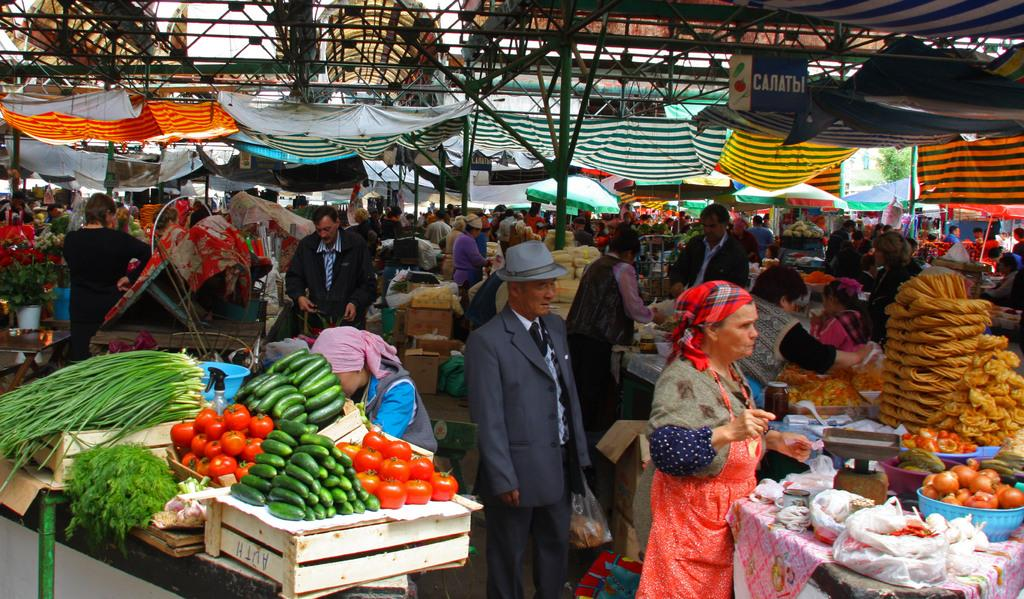Where was the image taken? The image was taken in a market. Are there any people in the image? Yes, there are persons in the image. What type of items can be seen in the image? Vegetables, tables, cardboard boxes, poles, tents, and food items are visible in the image. What is used for weighing items in the image? A weighing machine is present in the image. What type of mint can be seen growing near the tents in the image? There is no mint visible in the image; it only features a market setting with various items and people. 